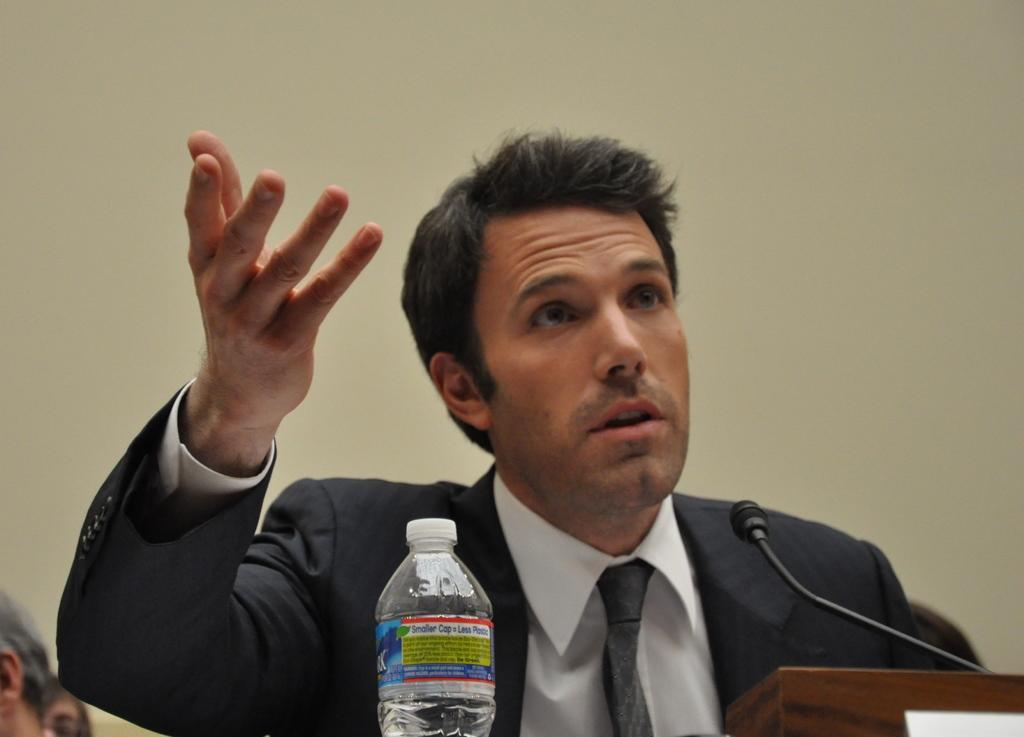In one or two sentences, can you explain what this image depicts? This image consists of a man who is standing near a podium. There is a mic on the podium and there is also a water bottle near him. He is wearing a blazer. 